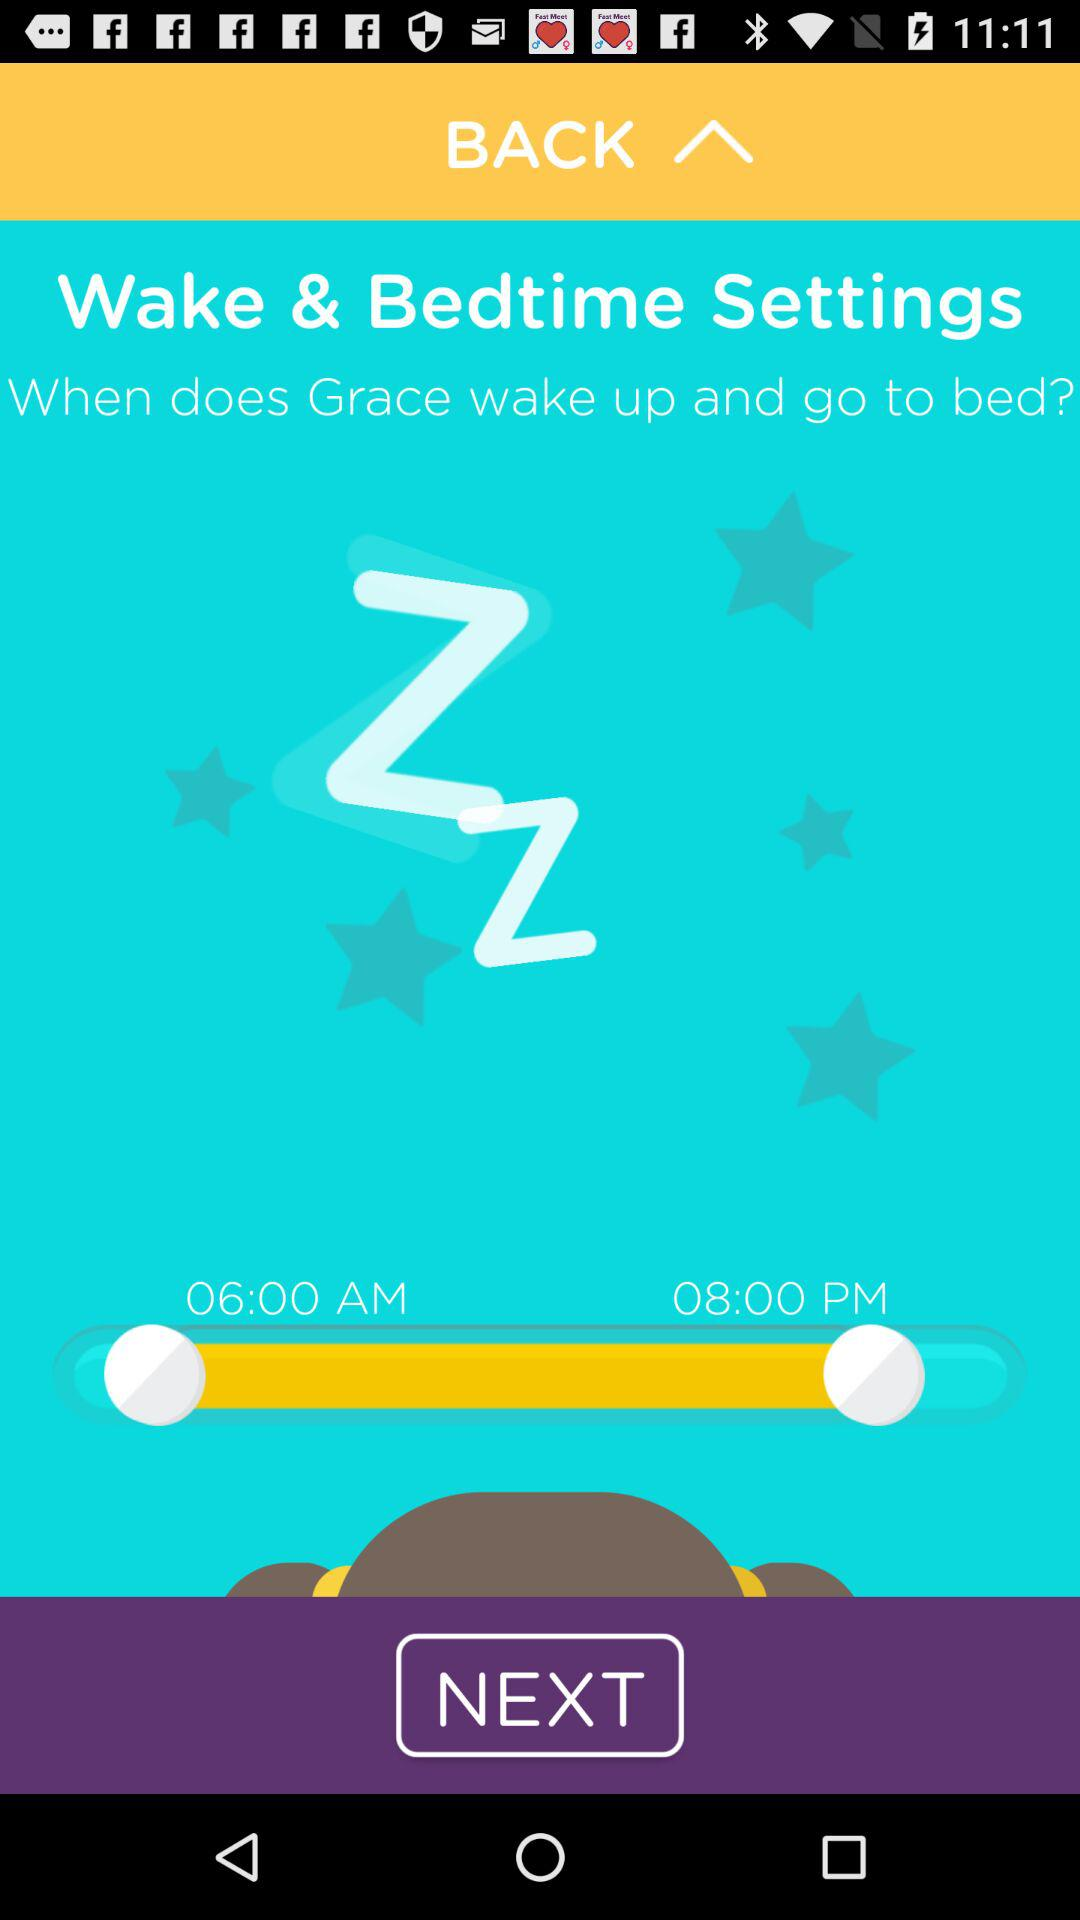How much earlier does Grace go to bed than she wakes up?
Answer the question using a single word or phrase. 2 hours 